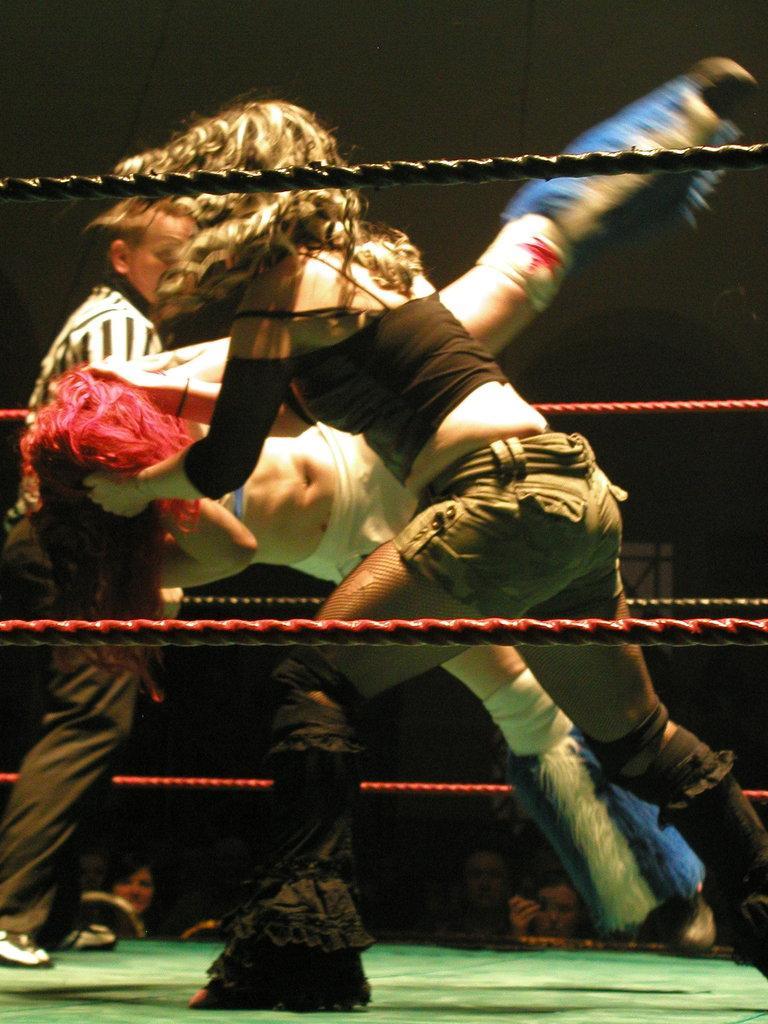How would you summarize this image in a sentence or two? This image consists of 3 persons. Two are a woman, one is a man. One is holding other persons head. 